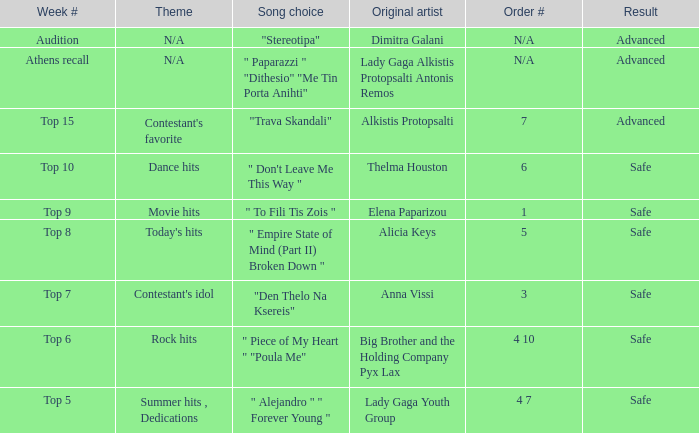Which week featured the song selection "empire state of mind (part ii) broken down"? Top 8. Can you parse all the data within this table? {'header': ['Week #', 'Theme', 'Song choice', 'Original artist', 'Order #', 'Result'], 'rows': [['Audition', 'N/A', '"Stereotipa"', 'Dimitra Galani', 'N/A', 'Advanced'], ['Athens recall', 'N/A', '" Paparazzi " "Dithesio" "Me Tin Porta Anihti"', 'Lady Gaga Alkistis Protopsalti Antonis Remos', 'N/A', 'Advanced'], ['Top 15', "Contestant's favorite", '"Trava Skandali"', 'Alkistis Protopsalti', '7', 'Advanced'], ['Top 10', 'Dance hits', '" Don\'t Leave Me This Way "', 'Thelma Houston', '6', 'Safe'], ['Top 9', 'Movie hits', '" To Fili Tis Zois "', 'Elena Paparizou', '1', 'Safe'], ['Top 8', "Today's hits", '" Empire State of Mind (Part II) Broken Down "', 'Alicia Keys', '5', 'Safe'], ['Top 7', "Contestant's idol", '"Den Thelo Na Ksereis"', 'Anna Vissi', '3', 'Safe'], ['Top 6', 'Rock hits', '" Piece of My Heart " "Poula Me"', 'Big Brother and the Holding Company Pyx Lax', '4 10', 'Safe'], ['Top 5', 'Summer hits , Dedications', '" Alejandro " " Forever Young "', 'Lady Gaga Youth Group', '4 7', 'Safe']]} 